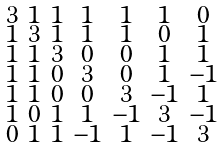<formula> <loc_0><loc_0><loc_500><loc_500>\begin{smallmatrix} 3 & 1 & 1 & 1 & 1 & 1 & 0 \\ 1 & 3 & 1 & 1 & 1 & 0 & 1 \\ 1 & 1 & 3 & 0 & 0 & 1 & 1 \\ 1 & 1 & 0 & 3 & 0 & 1 & - 1 \\ 1 & 1 & 0 & 0 & 3 & - 1 & 1 \\ 1 & 0 & 1 & 1 & - 1 & 3 & - 1 \\ 0 & 1 & 1 & - 1 & 1 & - 1 & 3 \end{smallmatrix}</formula> 